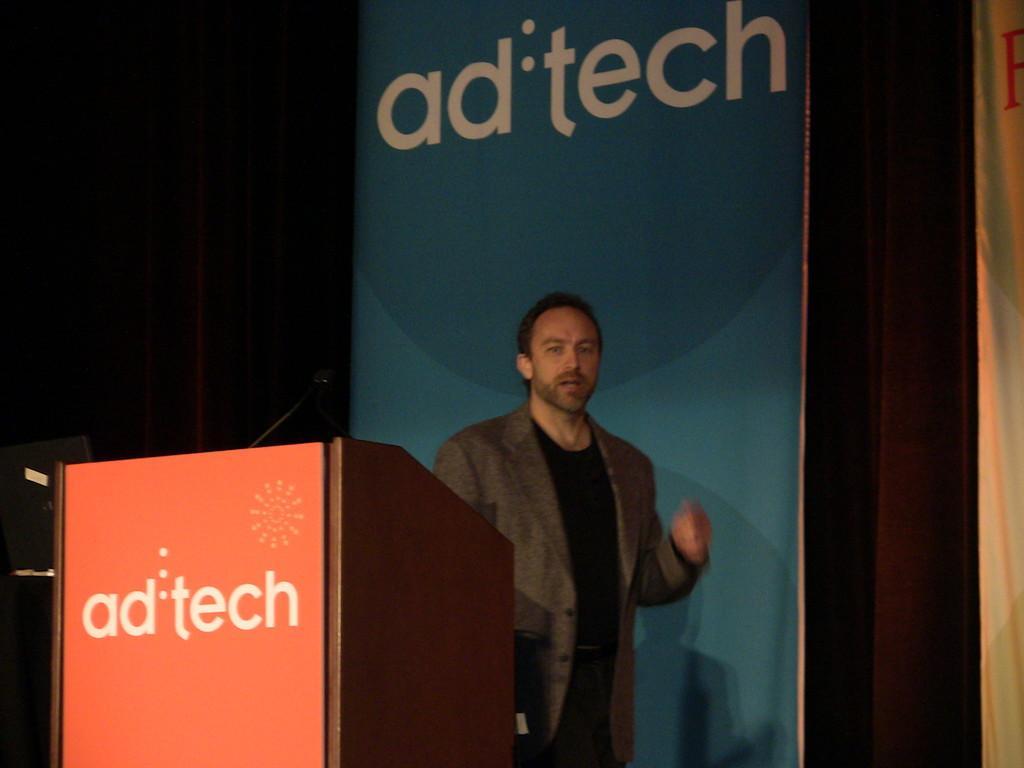Please provide a concise description of this image. There is a person, mic and a desk in the foreground, there are posters and curtain in the background. 